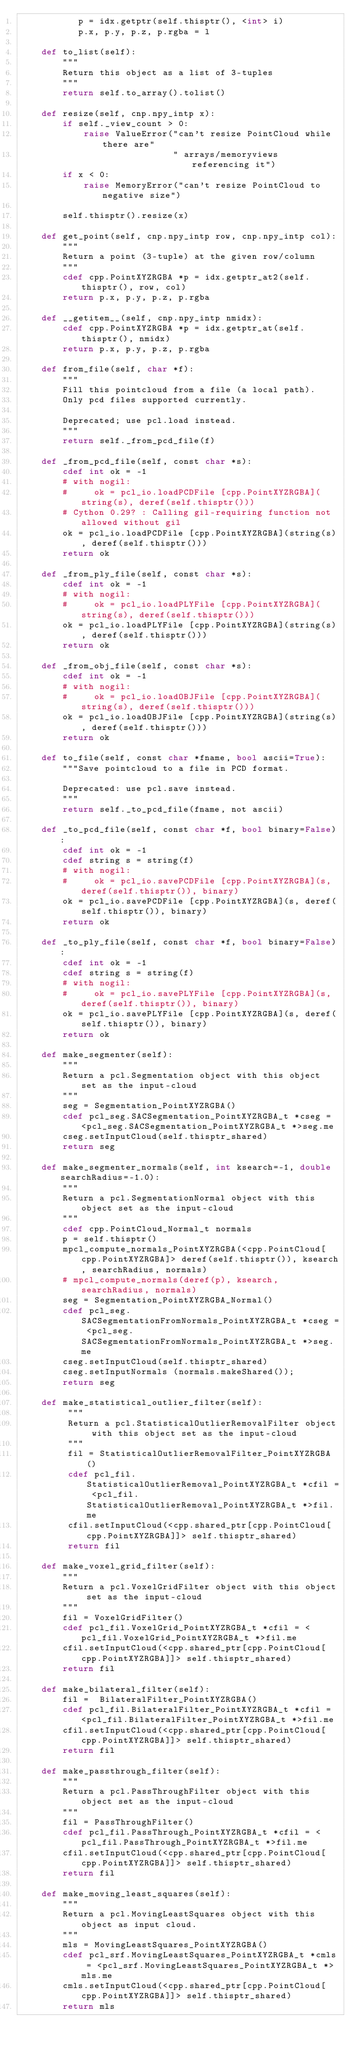Convert code to text. <code><loc_0><loc_0><loc_500><loc_500><_Cython_>           p = idx.getptr(self.thisptr(), <int> i)
           p.x, p.y, p.z, p.rgba = l

    def to_list(self):
        """
        Return this object as a list of 3-tuples
        """
        return self.to_array().tolist()

    def resize(self, cnp.npy_intp x):
        if self._view_count > 0:
            raise ValueError("can't resize PointCloud while there are"
                             " arrays/memoryviews referencing it")
        if x < 0:
            raise MemoryError("can't resize PointCloud to negative size")

        self.thisptr().resize(x)

    def get_point(self, cnp.npy_intp row, cnp.npy_intp col):
        """
        Return a point (3-tuple) at the given row/column
        """
        cdef cpp.PointXYZRGBA *p = idx.getptr_at2(self.thisptr(), row, col)
        return p.x, p.y, p.z, p.rgba

    def __getitem__(self, cnp.npy_intp nmidx):
        cdef cpp.PointXYZRGBA *p = idx.getptr_at(self.thisptr(), nmidx)
        return p.x, p.y, p.z, p.rgba

    def from_file(self, char *f):
        """
        Fill this pointcloud from a file (a local path).
        Only pcd files supported currently.
        
        Deprecated; use pcl.load instead.
        """
        return self._from_pcd_file(f)

    def _from_pcd_file(self, const char *s):
        cdef int ok = -1
        # with nogil:
        #     ok = pcl_io.loadPCDFile [cpp.PointXYZRGBA](string(s), deref(self.thisptr()))
        # Cython 0.29? : Calling gil-requiring function not allowed without gil
        ok = pcl_io.loadPCDFile [cpp.PointXYZRGBA](string(s), deref(self.thisptr()))
        return ok

    def _from_ply_file(self, const char *s):
        cdef int ok = -1
        # with nogil:
        #     ok = pcl_io.loadPLYFile [cpp.PointXYZRGBA](string(s), deref(self.thisptr()))
        ok = pcl_io.loadPLYFile [cpp.PointXYZRGBA](string(s), deref(self.thisptr()))
        return ok

    def _from_obj_file(self, const char *s):
        cdef int ok = -1
        # with nogil:
        #     ok = pcl_io.loadOBJFile [cpp.PointXYZRGBA](string(s), deref(self.thisptr()))
        ok = pcl_io.loadOBJFile [cpp.PointXYZRGBA](string(s), deref(self.thisptr()))
        return ok

    def to_file(self, const char *fname, bool ascii=True):
        """Save pointcloud to a file in PCD format.

        Deprecated: use pcl.save instead.
        """
        return self._to_pcd_file(fname, not ascii)

    def _to_pcd_file(self, const char *f, bool binary=False):
        cdef int ok = -1
        cdef string s = string(f)
        # with nogil:
        #     ok = pcl_io.savePCDFile [cpp.PointXYZRGBA](s, deref(self.thisptr()), binary)
        ok = pcl_io.savePCDFile [cpp.PointXYZRGBA](s, deref(self.thisptr()), binary)
        return ok

    def _to_ply_file(self, const char *f, bool binary=False):
        cdef int ok = -1
        cdef string s = string(f)
        # with nogil:
        #     ok = pcl_io.savePLYFile [cpp.PointXYZRGBA](s, deref(self.thisptr()), binary)
        ok = pcl_io.savePLYFile [cpp.PointXYZRGBA](s, deref(self.thisptr()), binary)
        return ok

    def make_segmenter(self):
        """
        Return a pcl.Segmentation object with this object set as the input-cloud
        """
        seg = Segmentation_PointXYZRGBA()
        cdef pcl_seg.SACSegmentation_PointXYZRGBA_t *cseg = <pcl_seg.SACSegmentation_PointXYZRGBA_t *>seg.me
        cseg.setInputCloud(self.thisptr_shared)
        return seg

    def make_segmenter_normals(self, int ksearch=-1, double searchRadius=-1.0):
        """
        Return a pcl.SegmentationNormal object with this object set as the input-cloud
        """
        cdef cpp.PointCloud_Normal_t normals
        p = self.thisptr()
        mpcl_compute_normals_PointXYZRGBA(<cpp.PointCloud[cpp.PointXYZRGBA]> deref(self.thisptr()), ksearch, searchRadius, normals)
        # mpcl_compute_normals(deref(p), ksearch, searchRadius, normals)
        seg = Segmentation_PointXYZRGBA_Normal()
        cdef pcl_seg.SACSegmentationFromNormals_PointXYZRGBA_t *cseg = <pcl_seg.SACSegmentationFromNormals_PointXYZRGBA_t *>seg.me
        cseg.setInputCloud(self.thisptr_shared)
        cseg.setInputNormals (normals.makeShared());
        return seg

    def make_statistical_outlier_filter(self):
         """
         Return a pcl.StatisticalOutlierRemovalFilter object with this object set as the input-cloud
         """
         fil = StatisticalOutlierRemovalFilter_PointXYZRGBA()
         cdef pcl_fil.StatisticalOutlierRemoval_PointXYZRGBA_t *cfil = <pcl_fil.StatisticalOutlierRemoval_PointXYZRGBA_t *>fil.me
         cfil.setInputCloud(<cpp.shared_ptr[cpp.PointCloud[cpp.PointXYZRGBA]]> self.thisptr_shared)
         return fil

    def make_voxel_grid_filter(self):
        """
        Return a pcl.VoxelGridFilter object with this object set as the input-cloud
        """
        fil = VoxelGridFilter()
        cdef pcl_fil.VoxelGrid_PointXYZRGBA_t *cfil = <pcl_fil.VoxelGrid_PointXYZRGBA_t *>fil.me
        cfil.setInputCloud(<cpp.shared_ptr[cpp.PointCloud[cpp.PointXYZRGBA]]> self.thisptr_shared)
        return fil

    def make_bilateral_filter(self):
        fil =  BilateralFilter_PointXYZRGBA()
        cdef pcl_fil.BilateralFilter_PointXYZRGBA_t *cfil = <pcl_fil.BilateralFilter_PointXYZRGBA_t *>fil.me
        cfil.setInputCloud(<cpp.shared_ptr[cpp.PointCloud[cpp.PointXYZRGBA]]> self.thisptr_shared)
        return fil

    def make_passthrough_filter(self):
        """
        Return a pcl.PassThroughFilter object with this object set as the input-cloud
        """
        fil = PassThroughFilter()
        cdef pcl_fil.PassThrough_PointXYZRGBA_t *cfil = <pcl_fil.PassThrough_PointXYZRGBA_t *>fil.me
        cfil.setInputCloud(<cpp.shared_ptr[cpp.PointCloud[cpp.PointXYZRGBA]]> self.thisptr_shared)
        return fil

    def make_moving_least_squares(self):
        """
        Return a pcl.MovingLeastSquares object with this object as input cloud.
        """
        mls = MovingLeastSquares_PointXYZRGBA()
        cdef pcl_srf.MovingLeastSquares_PointXYZRGBA_t *cmls = <pcl_srf.MovingLeastSquares_PointXYZRGBA_t *>mls.me
        cmls.setInputCloud(<cpp.shared_ptr[cpp.PointCloud[cpp.PointXYZRGBA]]> self.thisptr_shared)
        return mls
</code> 